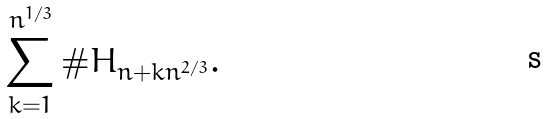<formula> <loc_0><loc_0><loc_500><loc_500>\sum _ { k = 1 } ^ { n ^ { 1 / 3 } } \# H _ { n + k n ^ { 2 / 3 } } .</formula> 